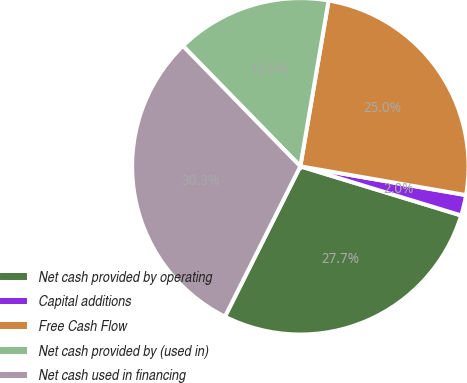Convert chart to OTSL. <chart><loc_0><loc_0><loc_500><loc_500><pie_chart><fcel>Net cash provided by operating<fcel>Capital additions<fcel>Free Cash Flow<fcel>Net cash provided by (used in)<fcel>Net cash used in financing<nl><fcel>27.68%<fcel>1.98%<fcel>25.05%<fcel>14.99%<fcel>30.3%<nl></chart> 